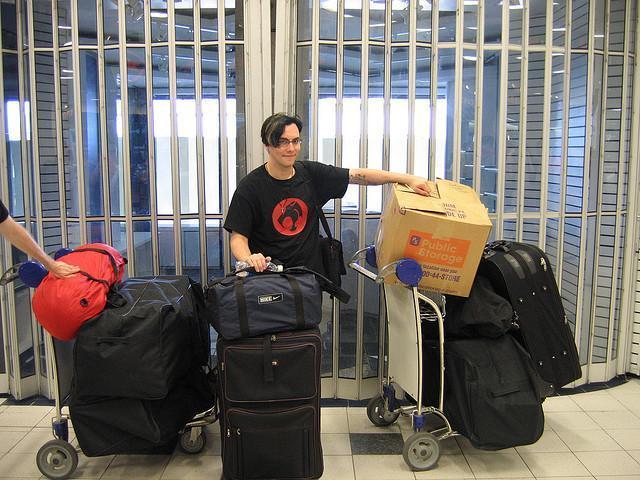How many backpacks are visible?
Give a very brief answer. 2. How many suitcases can you see?
Give a very brief answer. 6. 